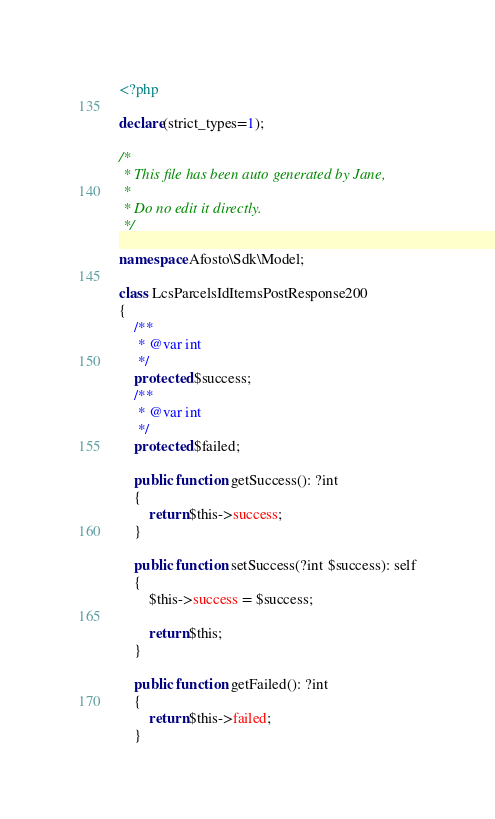<code> <loc_0><loc_0><loc_500><loc_500><_PHP_><?php

declare(strict_types=1);

/*
 * This file has been auto generated by Jane,
 *
 * Do no edit it directly.
 */

namespace Afosto\Sdk\Model;

class LcsParcelsIdItemsPostResponse200
{
    /**
     * @var int
     */
    protected $success;
    /**
     * @var int
     */
    protected $failed;

    public function getSuccess(): ?int
    {
        return $this->success;
    }

    public function setSuccess(?int $success): self
    {
        $this->success = $success;

        return $this;
    }

    public function getFailed(): ?int
    {
        return $this->failed;
    }
</code> 